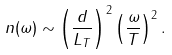Convert formula to latex. <formula><loc_0><loc_0><loc_500><loc_500>n ( \omega ) \sim \left ( \frac { d } { L _ { T } } \right ) ^ { 2 } \left ( \frac { \omega } { T } \right ) ^ { 2 } .</formula> 